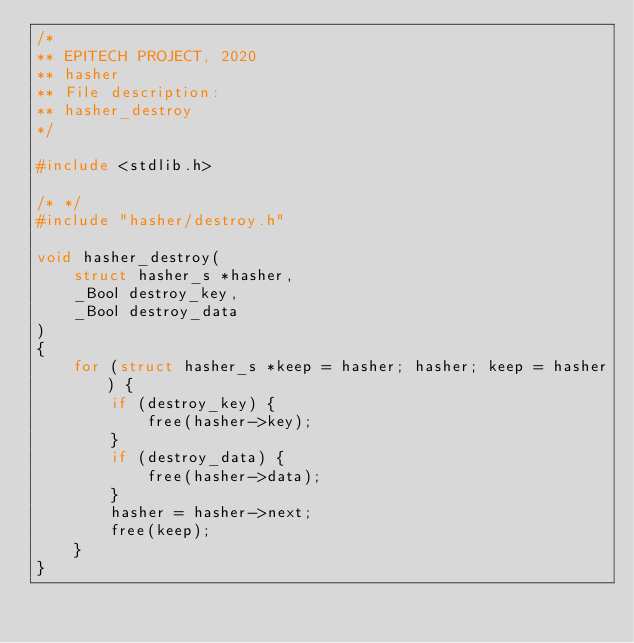Convert code to text. <code><loc_0><loc_0><loc_500><loc_500><_C_>/*
** EPITECH PROJECT, 2020
** hasher
** File description:
** hasher_destroy
*/

#include <stdlib.h>

/* */
#include "hasher/destroy.h"

void hasher_destroy(
    struct hasher_s *hasher,
    _Bool destroy_key,
    _Bool destroy_data
)
{
    for (struct hasher_s *keep = hasher; hasher; keep = hasher) {
        if (destroy_key) {
            free(hasher->key);
        }
        if (destroy_data) {
            free(hasher->data);
        }
        hasher = hasher->next;
        free(keep);
    }
}
</code> 